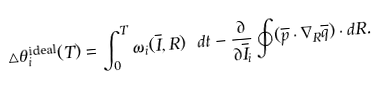<formula> <loc_0><loc_0><loc_500><loc_500>\triangle \theta _ { i } ^ { \text {ideal} } ( T ) = \int _ { 0 } ^ { T } \omega _ { i } ( \overline { I } , R ) \ d t - \frac { \partial } { \partial \overline { I } _ { i } } \oint ( \overline { p } \cdot \nabla _ { R } \overline { q } ) \cdot d R .</formula> 